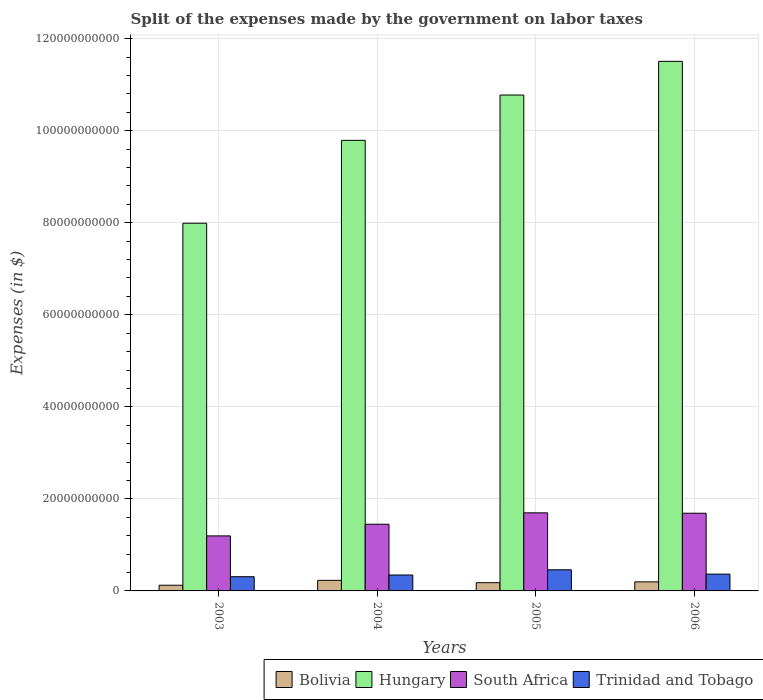How many groups of bars are there?
Offer a terse response. 4. Are the number of bars per tick equal to the number of legend labels?
Offer a very short reply. Yes. Are the number of bars on each tick of the X-axis equal?
Offer a terse response. Yes. How many bars are there on the 2nd tick from the left?
Make the answer very short. 4. What is the expenses made by the government on labor taxes in Hungary in 2003?
Your response must be concise. 7.99e+1. Across all years, what is the maximum expenses made by the government on labor taxes in Bolivia?
Provide a succinct answer. 2.29e+09. Across all years, what is the minimum expenses made by the government on labor taxes in Hungary?
Provide a succinct answer. 7.99e+1. In which year was the expenses made by the government on labor taxes in South Africa maximum?
Offer a very short reply. 2005. What is the total expenses made by the government on labor taxes in Trinidad and Tobago in the graph?
Ensure brevity in your answer.  1.48e+1. What is the difference between the expenses made by the government on labor taxes in Trinidad and Tobago in 2003 and that in 2004?
Provide a succinct answer. -3.72e+08. What is the difference between the expenses made by the government on labor taxes in Trinidad and Tobago in 2005 and the expenses made by the government on labor taxes in South Africa in 2006?
Make the answer very short. -1.23e+1. What is the average expenses made by the government on labor taxes in Bolivia per year?
Your answer should be very brief. 1.82e+09. In the year 2003, what is the difference between the expenses made by the government on labor taxes in Bolivia and expenses made by the government on labor taxes in Trinidad and Tobago?
Make the answer very short. -1.85e+09. What is the ratio of the expenses made by the government on labor taxes in Bolivia in 2004 to that in 2005?
Keep it short and to the point. 1.28. Is the expenses made by the government on labor taxes in Trinidad and Tobago in 2003 less than that in 2004?
Make the answer very short. Yes. Is the difference between the expenses made by the government on labor taxes in Bolivia in 2004 and 2005 greater than the difference between the expenses made by the government on labor taxes in Trinidad and Tobago in 2004 and 2005?
Offer a very short reply. Yes. What is the difference between the highest and the second highest expenses made by the government on labor taxes in South Africa?
Offer a very short reply. 8.20e+07. What is the difference between the highest and the lowest expenses made by the government on labor taxes in Hungary?
Provide a short and direct response. 3.52e+1. In how many years, is the expenses made by the government on labor taxes in Trinidad and Tobago greater than the average expenses made by the government on labor taxes in Trinidad and Tobago taken over all years?
Offer a very short reply. 1. What does the 4th bar from the left in 2006 represents?
Keep it short and to the point. Trinidad and Tobago. What does the 4th bar from the right in 2006 represents?
Your answer should be very brief. Bolivia. How many bars are there?
Keep it short and to the point. 16. Are all the bars in the graph horizontal?
Provide a short and direct response. No. How many years are there in the graph?
Offer a terse response. 4. Does the graph contain grids?
Provide a succinct answer. Yes. How many legend labels are there?
Your answer should be compact. 4. What is the title of the graph?
Offer a terse response. Split of the expenses made by the government on labor taxes. What is the label or title of the X-axis?
Ensure brevity in your answer.  Years. What is the label or title of the Y-axis?
Your response must be concise. Expenses (in $). What is the Expenses (in $) of Bolivia in 2003?
Keep it short and to the point. 1.24e+09. What is the Expenses (in $) in Hungary in 2003?
Provide a succinct answer. 7.99e+1. What is the Expenses (in $) of South Africa in 2003?
Give a very brief answer. 1.20e+1. What is the Expenses (in $) in Trinidad and Tobago in 2003?
Your answer should be very brief. 3.09e+09. What is the Expenses (in $) in Bolivia in 2004?
Provide a short and direct response. 2.29e+09. What is the Expenses (in $) in Hungary in 2004?
Offer a very short reply. 9.79e+1. What is the Expenses (in $) in South Africa in 2004?
Keep it short and to the point. 1.45e+1. What is the Expenses (in $) in Trinidad and Tobago in 2004?
Offer a terse response. 3.46e+09. What is the Expenses (in $) in Bolivia in 2005?
Your answer should be compact. 1.79e+09. What is the Expenses (in $) of Hungary in 2005?
Provide a short and direct response. 1.08e+11. What is the Expenses (in $) in South Africa in 2005?
Your response must be concise. 1.70e+1. What is the Expenses (in $) of Trinidad and Tobago in 2005?
Offer a very short reply. 4.59e+09. What is the Expenses (in $) in Bolivia in 2006?
Provide a succinct answer. 1.97e+09. What is the Expenses (in $) in Hungary in 2006?
Your answer should be compact. 1.15e+11. What is the Expenses (in $) in South Africa in 2006?
Make the answer very short. 1.69e+1. What is the Expenses (in $) in Trinidad and Tobago in 2006?
Your answer should be compact. 3.65e+09. Across all years, what is the maximum Expenses (in $) in Bolivia?
Make the answer very short. 2.29e+09. Across all years, what is the maximum Expenses (in $) in Hungary?
Give a very brief answer. 1.15e+11. Across all years, what is the maximum Expenses (in $) of South Africa?
Offer a terse response. 1.70e+1. Across all years, what is the maximum Expenses (in $) of Trinidad and Tobago?
Keep it short and to the point. 4.59e+09. Across all years, what is the minimum Expenses (in $) in Bolivia?
Give a very brief answer. 1.24e+09. Across all years, what is the minimum Expenses (in $) in Hungary?
Make the answer very short. 7.99e+1. Across all years, what is the minimum Expenses (in $) of South Africa?
Your response must be concise. 1.20e+1. Across all years, what is the minimum Expenses (in $) of Trinidad and Tobago?
Your answer should be compact. 3.09e+09. What is the total Expenses (in $) in Bolivia in the graph?
Ensure brevity in your answer.  7.29e+09. What is the total Expenses (in $) of Hungary in the graph?
Provide a short and direct response. 4.01e+11. What is the total Expenses (in $) of South Africa in the graph?
Provide a succinct answer. 6.03e+1. What is the total Expenses (in $) in Trinidad and Tobago in the graph?
Your response must be concise. 1.48e+1. What is the difference between the Expenses (in $) of Bolivia in 2003 and that in 2004?
Make the answer very short. -1.06e+09. What is the difference between the Expenses (in $) of Hungary in 2003 and that in 2004?
Ensure brevity in your answer.  -1.80e+1. What is the difference between the Expenses (in $) in South Africa in 2003 and that in 2004?
Give a very brief answer. -2.54e+09. What is the difference between the Expenses (in $) in Trinidad and Tobago in 2003 and that in 2004?
Give a very brief answer. -3.72e+08. What is the difference between the Expenses (in $) of Bolivia in 2003 and that in 2005?
Give a very brief answer. -5.56e+08. What is the difference between the Expenses (in $) of Hungary in 2003 and that in 2005?
Make the answer very short. -2.78e+1. What is the difference between the Expenses (in $) of South Africa in 2003 and that in 2005?
Your answer should be compact. -5.01e+09. What is the difference between the Expenses (in $) in Trinidad and Tobago in 2003 and that in 2005?
Your answer should be compact. -1.50e+09. What is the difference between the Expenses (in $) in Bolivia in 2003 and that in 2006?
Ensure brevity in your answer.  -7.30e+08. What is the difference between the Expenses (in $) in Hungary in 2003 and that in 2006?
Your answer should be very brief. -3.52e+1. What is the difference between the Expenses (in $) of South Africa in 2003 and that in 2006?
Your response must be concise. -4.93e+09. What is the difference between the Expenses (in $) in Trinidad and Tobago in 2003 and that in 2006?
Offer a terse response. -5.64e+08. What is the difference between the Expenses (in $) in Bolivia in 2004 and that in 2005?
Provide a succinct answer. 5.03e+08. What is the difference between the Expenses (in $) of Hungary in 2004 and that in 2005?
Keep it short and to the point. -9.84e+09. What is the difference between the Expenses (in $) in South Africa in 2004 and that in 2005?
Offer a terse response. -2.47e+09. What is the difference between the Expenses (in $) in Trinidad and Tobago in 2004 and that in 2005?
Give a very brief answer. -1.13e+09. What is the difference between the Expenses (in $) in Bolivia in 2004 and that in 2006?
Offer a terse response. 3.29e+08. What is the difference between the Expenses (in $) in Hungary in 2004 and that in 2006?
Provide a succinct answer. -1.72e+1. What is the difference between the Expenses (in $) in South Africa in 2004 and that in 2006?
Offer a terse response. -2.39e+09. What is the difference between the Expenses (in $) of Trinidad and Tobago in 2004 and that in 2006?
Offer a terse response. -1.92e+08. What is the difference between the Expenses (in $) in Bolivia in 2005 and that in 2006?
Your response must be concise. -1.74e+08. What is the difference between the Expenses (in $) in Hungary in 2005 and that in 2006?
Make the answer very short. -7.32e+09. What is the difference between the Expenses (in $) in South Africa in 2005 and that in 2006?
Give a very brief answer. 8.20e+07. What is the difference between the Expenses (in $) of Trinidad and Tobago in 2005 and that in 2006?
Your answer should be very brief. 9.39e+08. What is the difference between the Expenses (in $) in Bolivia in 2003 and the Expenses (in $) in Hungary in 2004?
Offer a very short reply. -9.67e+1. What is the difference between the Expenses (in $) in Bolivia in 2003 and the Expenses (in $) in South Africa in 2004?
Offer a very short reply. -1.33e+1. What is the difference between the Expenses (in $) of Bolivia in 2003 and the Expenses (in $) of Trinidad and Tobago in 2004?
Make the answer very short. -2.22e+09. What is the difference between the Expenses (in $) of Hungary in 2003 and the Expenses (in $) of South Africa in 2004?
Offer a terse response. 6.54e+1. What is the difference between the Expenses (in $) of Hungary in 2003 and the Expenses (in $) of Trinidad and Tobago in 2004?
Your answer should be very brief. 7.64e+1. What is the difference between the Expenses (in $) in South Africa in 2003 and the Expenses (in $) in Trinidad and Tobago in 2004?
Offer a very short reply. 8.50e+09. What is the difference between the Expenses (in $) of Bolivia in 2003 and the Expenses (in $) of Hungary in 2005?
Keep it short and to the point. -1.07e+11. What is the difference between the Expenses (in $) of Bolivia in 2003 and the Expenses (in $) of South Africa in 2005?
Keep it short and to the point. -1.57e+1. What is the difference between the Expenses (in $) in Bolivia in 2003 and the Expenses (in $) in Trinidad and Tobago in 2005?
Offer a terse response. -3.36e+09. What is the difference between the Expenses (in $) in Hungary in 2003 and the Expenses (in $) in South Africa in 2005?
Offer a very short reply. 6.29e+1. What is the difference between the Expenses (in $) of Hungary in 2003 and the Expenses (in $) of Trinidad and Tobago in 2005?
Ensure brevity in your answer.  7.53e+1. What is the difference between the Expenses (in $) in South Africa in 2003 and the Expenses (in $) in Trinidad and Tobago in 2005?
Offer a very short reply. 7.37e+09. What is the difference between the Expenses (in $) of Bolivia in 2003 and the Expenses (in $) of Hungary in 2006?
Your answer should be very brief. -1.14e+11. What is the difference between the Expenses (in $) of Bolivia in 2003 and the Expenses (in $) of South Africa in 2006?
Ensure brevity in your answer.  -1.56e+1. What is the difference between the Expenses (in $) of Bolivia in 2003 and the Expenses (in $) of Trinidad and Tobago in 2006?
Provide a succinct answer. -2.42e+09. What is the difference between the Expenses (in $) of Hungary in 2003 and the Expenses (in $) of South Africa in 2006?
Provide a succinct answer. 6.30e+1. What is the difference between the Expenses (in $) of Hungary in 2003 and the Expenses (in $) of Trinidad and Tobago in 2006?
Your answer should be compact. 7.62e+1. What is the difference between the Expenses (in $) in South Africa in 2003 and the Expenses (in $) in Trinidad and Tobago in 2006?
Give a very brief answer. 8.30e+09. What is the difference between the Expenses (in $) of Bolivia in 2004 and the Expenses (in $) of Hungary in 2005?
Ensure brevity in your answer.  -1.05e+11. What is the difference between the Expenses (in $) in Bolivia in 2004 and the Expenses (in $) in South Africa in 2005?
Give a very brief answer. -1.47e+1. What is the difference between the Expenses (in $) in Bolivia in 2004 and the Expenses (in $) in Trinidad and Tobago in 2005?
Your response must be concise. -2.30e+09. What is the difference between the Expenses (in $) of Hungary in 2004 and the Expenses (in $) of South Africa in 2005?
Your answer should be very brief. 8.09e+1. What is the difference between the Expenses (in $) of Hungary in 2004 and the Expenses (in $) of Trinidad and Tobago in 2005?
Your answer should be compact. 9.33e+1. What is the difference between the Expenses (in $) in South Africa in 2004 and the Expenses (in $) in Trinidad and Tobago in 2005?
Offer a terse response. 9.90e+09. What is the difference between the Expenses (in $) of Bolivia in 2004 and the Expenses (in $) of Hungary in 2006?
Provide a succinct answer. -1.13e+11. What is the difference between the Expenses (in $) in Bolivia in 2004 and the Expenses (in $) in South Africa in 2006?
Provide a short and direct response. -1.46e+1. What is the difference between the Expenses (in $) of Bolivia in 2004 and the Expenses (in $) of Trinidad and Tobago in 2006?
Ensure brevity in your answer.  -1.36e+09. What is the difference between the Expenses (in $) in Hungary in 2004 and the Expenses (in $) in South Africa in 2006?
Ensure brevity in your answer.  8.10e+1. What is the difference between the Expenses (in $) of Hungary in 2004 and the Expenses (in $) of Trinidad and Tobago in 2006?
Ensure brevity in your answer.  9.43e+1. What is the difference between the Expenses (in $) of South Africa in 2004 and the Expenses (in $) of Trinidad and Tobago in 2006?
Offer a very short reply. 1.08e+1. What is the difference between the Expenses (in $) in Bolivia in 2005 and the Expenses (in $) in Hungary in 2006?
Make the answer very short. -1.13e+11. What is the difference between the Expenses (in $) in Bolivia in 2005 and the Expenses (in $) in South Africa in 2006?
Your response must be concise. -1.51e+1. What is the difference between the Expenses (in $) in Bolivia in 2005 and the Expenses (in $) in Trinidad and Tobago in 2006?
Your response must be concise. -1.86e+09. What is the difference between the Expenses (in $) of Hungary in 2005 and the Expenses (in $) of South Africa in 2006?
Your answer should be very brief. 9.09e+1. What is the difference between the Expenses (in $) of Hungary in 2005 and the Expenses (in $) of Trinidad and Tobago in 2006?
Give a very brief answer. 1.04e+11. What is the difference between the Expenses (in $) in South Africa in 2005 and the Expenses (in $) in Trinidad and Tobago in 2006?
Ensure brevity in your answer.  1.33e+1. What is the average Expenses (in $) of Bolivia per year?
Keep it short and to the point. 1.82e+09. What is the average Expenses (in $) in Hungary per year?
Your response must be concise. 1.00e+11. What is the average Expenses (in $) of South Africa per year?
Your answer should be very brief. 1.51e+1. What is the average Expenses (in $) in Trinidad and Tobago per year?
Offer a terse response. 3.70e+09. In the year 2003, what is the difference between the Expenses (in $) of Bolivia and Expenses (in $) of Hungary?
Your answer should be compact. -7.87e+1. In the year 2003, what is the difference between the Expenses (in $) in Bolivia and Expenses (in $) in South Africa?
Offer a terse response. -1.07e+1. In the year 2003, what is the difference between the Expenses (in $) of Bolivia and Expenses (in $) of Trinidad and Tobago?
Provide a short and direct response. -1.85e+09. In the year 2003, what is the difference between the Expenses (in $) in Hungary and Expenses (in $) in South Africa?
Your response must be concise. 6.79e+1. In the year 2003, what is the difference between the Expenses (in $) in Hungary and Expenses (in $) in Trinidad and Tobago?
Give a very brief answer. 7.68e+1. In the year 2003, what is the difference between the Expenses (in $) of South Africa and Expenses (in $) of Trinidad and Tobago?
Give a very brief answer. 8.87e+09. In the year 2004, what is the difference between the Expenses (in $) of Bolivia and Expenses (in $) of Hungary?
Provide a succinct answer. -9.56e+1. In the year 2004, what is the difference between the Expenses (in $) in Bolivia and Expenses (in $) in South Africa?
Offer a terse response. -1.22e+1. In the year 2004, what is the difference between the Expenses (in $) of Bolivia and Expenses (in $) of Trinidad and Tobago?
Your response must be concise. -1.17e+09. In the year 2004, what is the difference between the Expenses (in $) in Hungary and Expenses (in $) in South Africa?
Give a very brief answer. 8.34e+1. In the year 2004, what is the difference between the Expenses (in $) in Hungary and Expenses (in $) in Trinidad and Tobago?
Your answer should be very brief. 9.44e+1. In the year 2004, what is the difference between the Expenses (in $) of South Africa and Expenses (in $) of Trinidad and Tobago?
Provide a short and direct response. 1.10e+1. In the year 2005, what is the difference between the Expenses (in $) of Bolivia and Expenses (in $) of Hungary?
Give a very brief answer. -1.06e+11. In the year 2005, what is the difference between the Expenses (in $) in Bolivia and Expenses (in $) in South Africa?
Give a very brief answer. -1.52e+1. In the year 2005, what is the difference between the Expenses (in $) of Bolivia and Expenses (in $) of Trinidad and Tobago?
Keep it short and to the point. -2.80e+09. In the year 2005, what is the difference between the Expenses (in $) of Hungary and Expenses (in $) of South Africa?
Provide a succinct answer. 9.08e+1. In the year 2005, what is the difference between the Expenses (in $) in Hungary and Expenses (in $) in Trinidad and Tobago?
Ensure brevity in your answer.  1.03e+11. In the year 2005, what is the difference between the Expenses (in $) of South Africa and Expenses (in $) of Trinidad and Tobago?
Ensure brevity in your answer.  1.24e+1. In the year 2006, what is the difference between the Expenses (in $) of Bolivia and Expenses (in $) of Hungary?
Make the answer very short. -1.13e+11. In the year 2006, what is the difference between the Expenses (in $) of Bolivia and Expenses (in $) of South Africa?
Your response must be concise. -1.49e+1. In the year 2006, what is the difference between the Expenses (in $) in Bolivia and Expenses (in $) in Trinidad and Tobago?
Your answer should be compact. -1.69e+09. In the year 2006, what is the difference between the Expenses (in $) in Hungary and Expenses (in $) in South Africa?
Offer a terse response. 9.82e+1. In the year 2006, what is the difference between the Expenses (in $) of Hungary and Expenses (in $) of Trinidad and Tobago?
Offer a terse response. 1.11e+11. In the year 2006, what is the difference between the Expenses (in $) of South Africa and Expenses (in $) of Trinidad and Tobago?
Make the answer very short. 1.32e+1. What is the ratio of the Expenses (in $) of Bolivia in 2003 to that in 2004?
Make the answer very short. 0.54. What is the ratio of the Expenses (in $) in Hungary in 2003 to that in 2004?
Keep it short and to the point. 0.82. What is the ratio of the Expenses (in $) in South Africa in 2003 to that in 2004?
Ensure brevity in your answer.  0.82. What is the ratio of the Expenses (in $) in Trinidad and Tobago in 2003 to that in 2004?
Provide a short and direct response. 0.89. What is the ratio of the Expenses (in $) of Bolivia in 2003 to that in 2005?
Offer a very short reply. 0.69. What is the ratio of the Expenses (in $) of Hungary in 2003 to that in 2005?
Provide a succinct answer. 0.74. What is the ratio of the Expenses (in $) in South Africa in 2003 to that in 2005?
Keep it short and to the point. 0.7. What is the ratio of the Expenses (in $) of Trinidad and Tobago in 2003 to that in 2005?
Offer a terse response. 0.67. What is the ratio of the Expenses (in $) in Bolivia in 2003 to that in 2006?
Provide a succinct answer. 0.63. What is the ratio of the Expenses (in $) of Hungary in 2003 to that in 2006?
Provide a succinct answer. 0.69. What is the ratio of the Expenses (in $) in South Africa in 2003 to that in 2006?
Make the answer very short. 0.71. What is the ratio of the Expenses (in $) of Trinidad and Tobago in 2003 to that in 2006?
Make the answer very short. 0.85. What is the ratio of the Expenses (in $) in Bolivia in 2004 to that in 2005?
Ensure brevity in your answer.  1.28. What is the ratio of the Expenses (in $) in Hungary in 2004 to that in 2005?
Provide a succinct answer. 0.91. What is the ratio of the Expenses (in $) in South Africa in 2004 to that in 2005?
Ensure brevity in your answer.  0.85. What is the ratio of the Expenses (in $) in Trinidad and Tobago in 2004 to that in 2005?
Your answer should be very brief. 0.75. What is the ratio of the Expenses (in $) in Bolivia in 2004 to that in 2006?
Offer a very short reply. 1.17. What is the ratio of the Expenses (in $) of Hungary in 2004 to that in 2006?
Your answer should be very brief. 0.85. What is the ratio of the Expenses (in $) of South Africa in 2004 to that in 2006?
Your response must be concise. 0.86. What is the ratio of the Expenses (in $) of Bolivia in 2005 to that in 2006?
Make the answer very short. 0.91. What is the ratio of the Expenses (in $) of Hungary in 2005 to that in 2006?
Keep it short and to the point. 0.94. What is the ratio of the Expenses (in $) of South Africa in 2005 to that in 2006?
Your answer should be very brief. 1. What is the ratio of the Expenses (in $) in Trinidad and Tobago in 2005 to that in 2006?
Provide a short and direct response. 1.26. What is the difference between the highest and the second highest Expenses (in $) of Bolivia?
Provide a short and direct response. 3.29e+08. What is the difference between the highest and the second highest Expenses (in $) of Hungary?
Make the answer very short. 7.32e+09. What is the difference between the highest and the second highest Expenses (in $) in South Africa?
Keep it short and to the point. 8.20e+07. What is the difference between the highest and the second highest Expenses (in $) of Trinidad and Tobago?
Give a very brief answer. 9.39e+08. What is the difference between the highest and the lowest Expenses (in $) of Bolivia?
Ensure brevity in your answer.  1.06e+09. What is the difference between the highest and the lowest Expenses (in $) of Hungary?
Ensure brevity in your answer.  3.52e+1. What is the difference between the highest and the lowest Expenses (in $) of South Africa?
Your answer should be very brief. 5.01e+09. What is the difference between the highest and the lowest Expenses (in $) in Trinidad and Tobago?
Keep it short and to the point. 1.50e+09. 